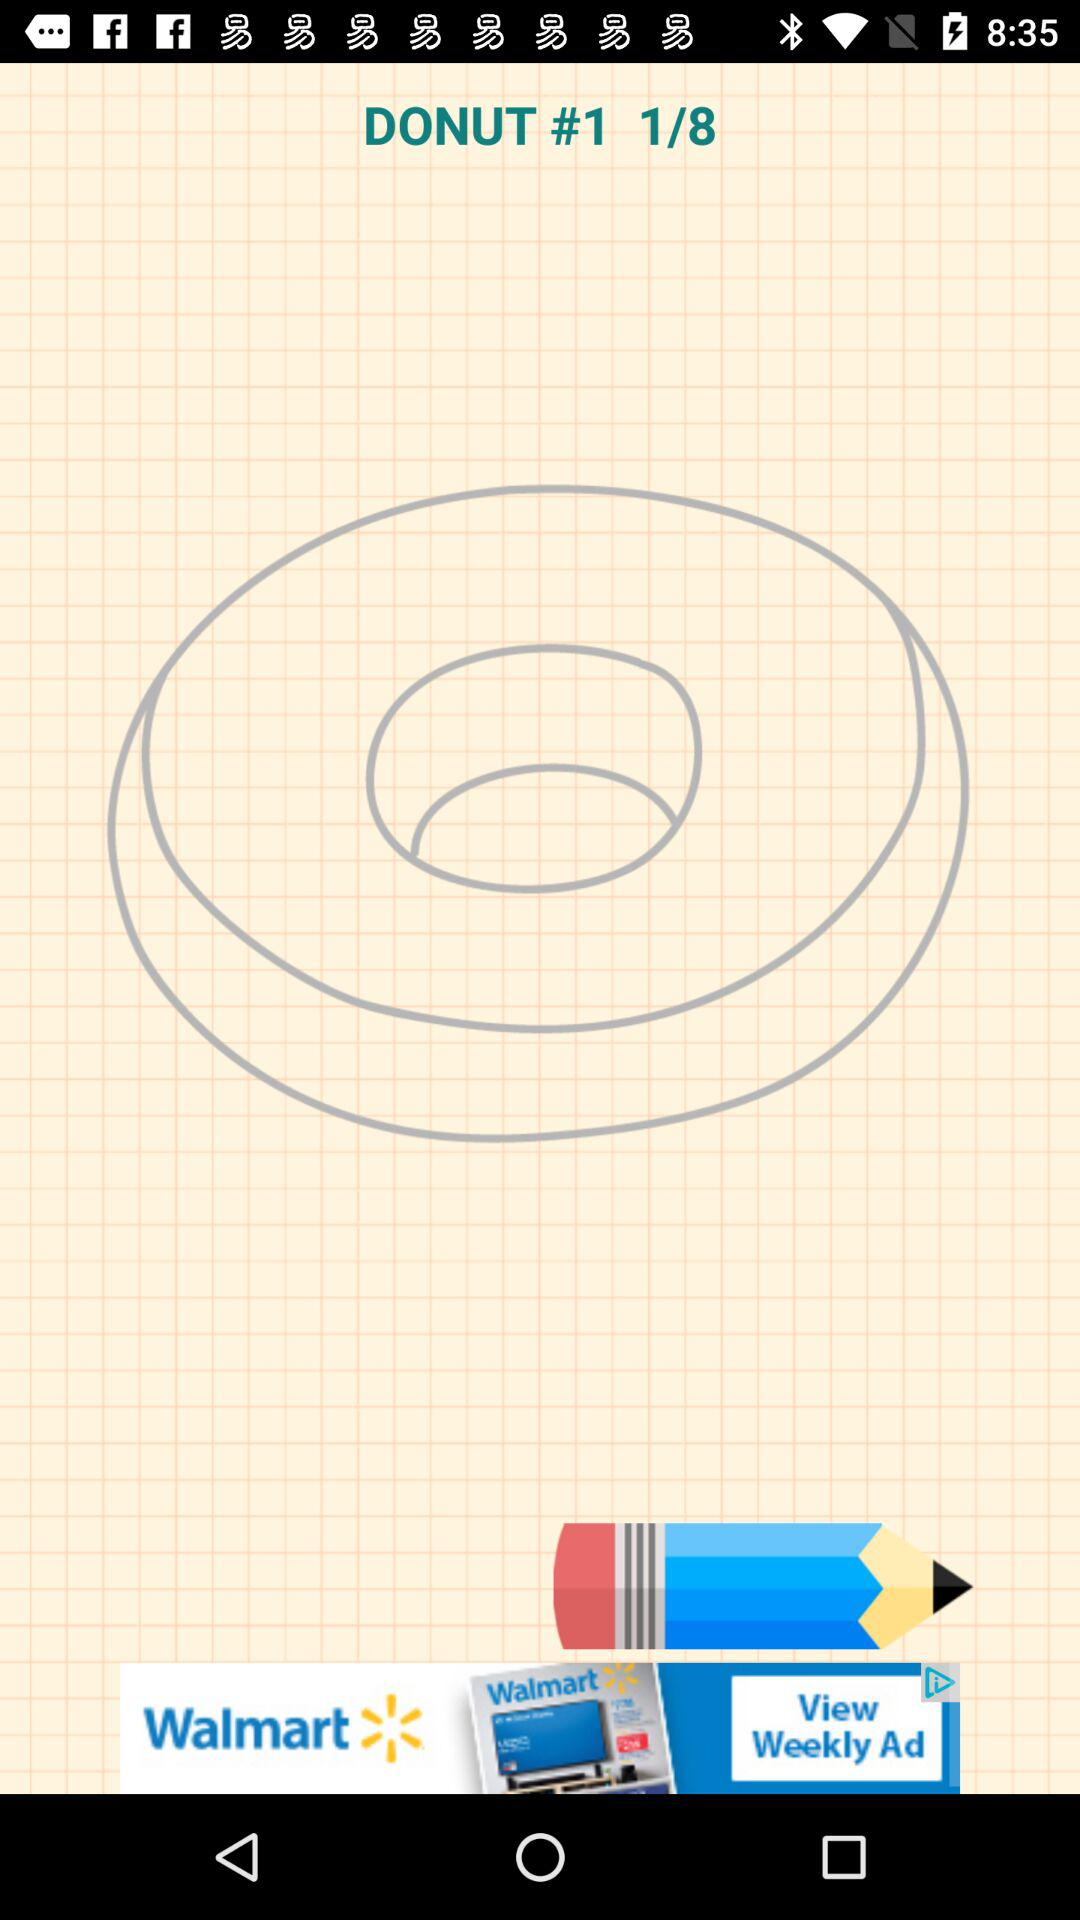Which page number are we currently on? You are currently on page number 1. 